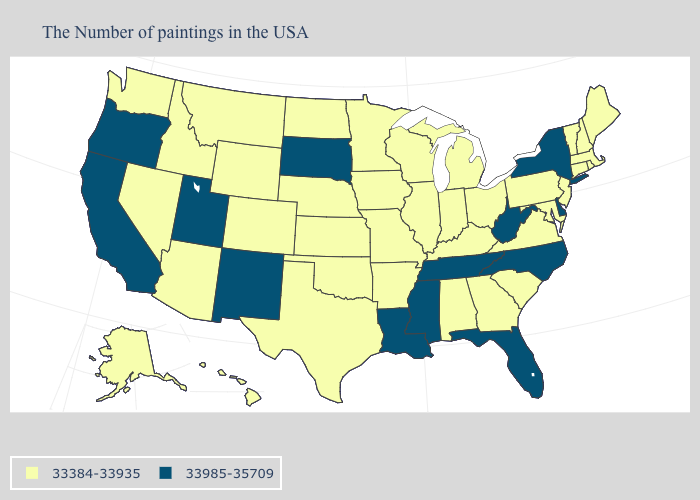What is the lowest value in the USA?
Short answer required. 33384-33935. Which states hav the highest value in the South?
Be succinct. Delaware, North Carolina, West Virginia, Florida, Tennessee, Mississippi, Louisiana. What is the value of Missouri?
Concise answer only. 33384-33935. Which states have the highest value in the USA?
Keep it brief. New York, Delaware, North Carolina, West Virginia, Florida, Tennessee, Mississippi, Louisiana, South Dakota, New Mexico, Utah, California, Oregon. What is the value of Nebraska?
Write a very short answer. 33384-33935. Name the states that have a value in the range 33384-33935?
Answer briefly. Maine, Massachusetts, Rhode Island, New Hampshire, Vermont, Connecticut, New Jersey, Maryland, Pennsylvania, Virginia, South Carolina, Ohio, Georgia, Michigan, Kentucky, Indiana, Alabama, Wisconsin, Illinois, Missouri, Arkansas, Minnesota, Iowa, Kansas, Nebraska, Oklahoma, Texas, North Dakota, Wyoming, Colorado, Montana, Arizona, Idaho, Nevada, Washington, Alaska, Hawaii. What is the lowest value in the USA?
Short answer required. 33384-33935. What is the highest value in states that border Alabama?
Give a very brief answer. 33985-35709. What is the value of Maine?
Short answer required. 33384-33935. Does the first symbol in the legend represent the smallest category?
Give a very brief answer. Yes. What is the value of Tennessee?
Give a very brief answer. 33985-35709. What is the value of Delaware?
Give a very brief answer. 33985-35709. Name the states that have a value in the range 33384-33935?
Short answer required. Maine, Massachusetts, Rhode Island, New Hampshire, Vermont, Connecticut, New Jersey, Maryland, Pennsylvania, Virginia, South Carolina, Ohio, Georgia, Michigan, Kentucky, Indiana, Alabama, Wisconsin, Illinois, Missouri, Arkansas, Minnesota, Iowa, Kansas, Nebraska, Oklahoma, Texas, North Dakota, Wyoming, Colorado, Montana, Arizona, Idaho, Nevada, Washington, Alaska, Hawaii. What is the value of South Carolina?
Give a very brief answer. 33384-33935. What is the value of Oklahoma?
Write a very short answer. 33384-33935. 